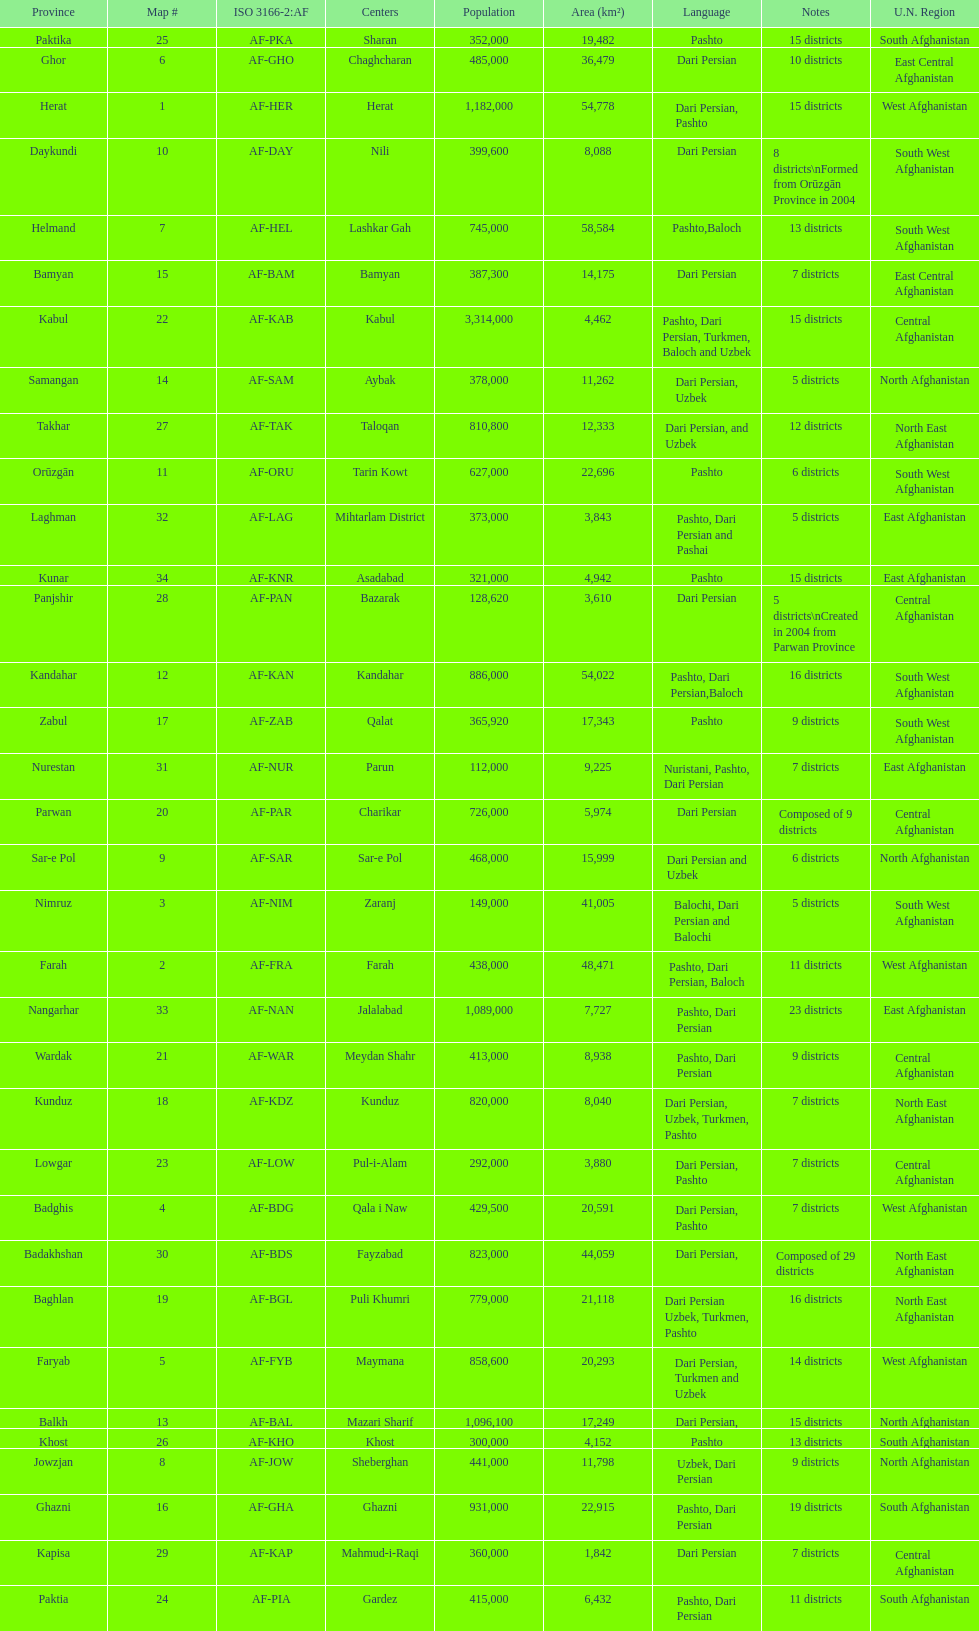Does ghor or farah have more districts? Farah. 